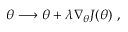<formula> <loc_0><loc_0><loc_500><loc_500>\theta \longrightarrow \theta + \lambda \nabla _ { \theta } J ( \theta ) ,</formula> 